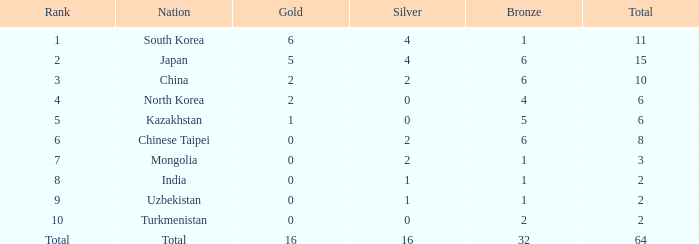How many Golds did Rank 10 get, with a Bronze larger than 2? 0.0. I'm looking to parse the entire table for insights. Could you assist me with that? {'header': ['Rank', 'Nation', 'Gold', 'Silver', 'Bronze', 'Total'], 'rows': [['1', 'South Korea', '6', '4', '1', '11'], ['2', 'Japan', '5', '4', '6', '15'], ['3', 'China', '2', '2', '6', '10'], ['4', 'North Korea', '2', '0', '4', '6'], ['5', 'Kazakhstan', '1', '0', '5', '6'], ['6', 'Chinese Taipei', '0', '2', '6', '8'], ['7', 'Mongolia', '0', '2', '1', '3'], ['8', 'India', '0', '1', '1', '2'], ['9', 'Uzbekistan', '0', '1', '1', '2'], ['10', 'Turkmenistan', '0', '0', '2', '2'], ['Total', 'Total', '16', '16', '32', '64']]} 